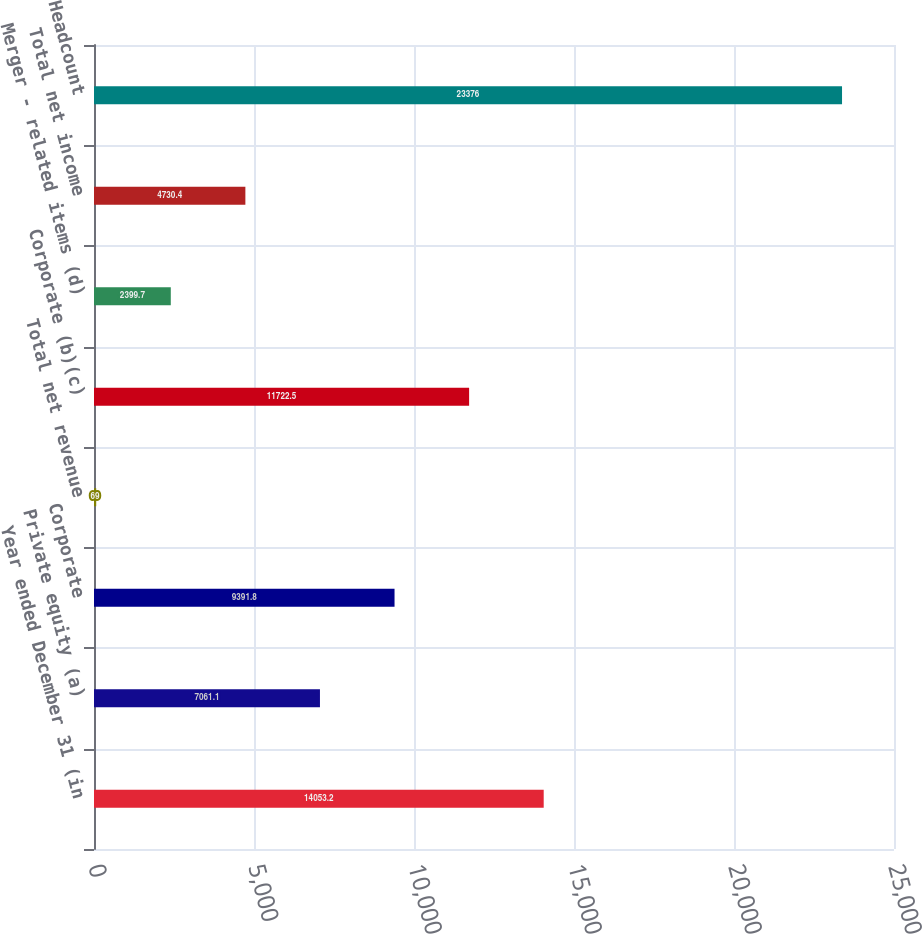<chart> <loc_0><loc_0><loc_500><loc_500><bar_chart><fcel>Year ended December 31 (in<fcel>Private equity (a)<fcel>Corporate<fcel>Total net revenue<fcel>Corporate (b)(c)<fcel>Merger - related items (d)<fcel>Total net income<fcel>Headcount<nl><fcel>14053.2<fcel>7061.1<fcel>9391.8<fcel>69<fcel>11722.5<fcel>2399.7<fcel>4730.4<fcel>23376<nl></chart> 